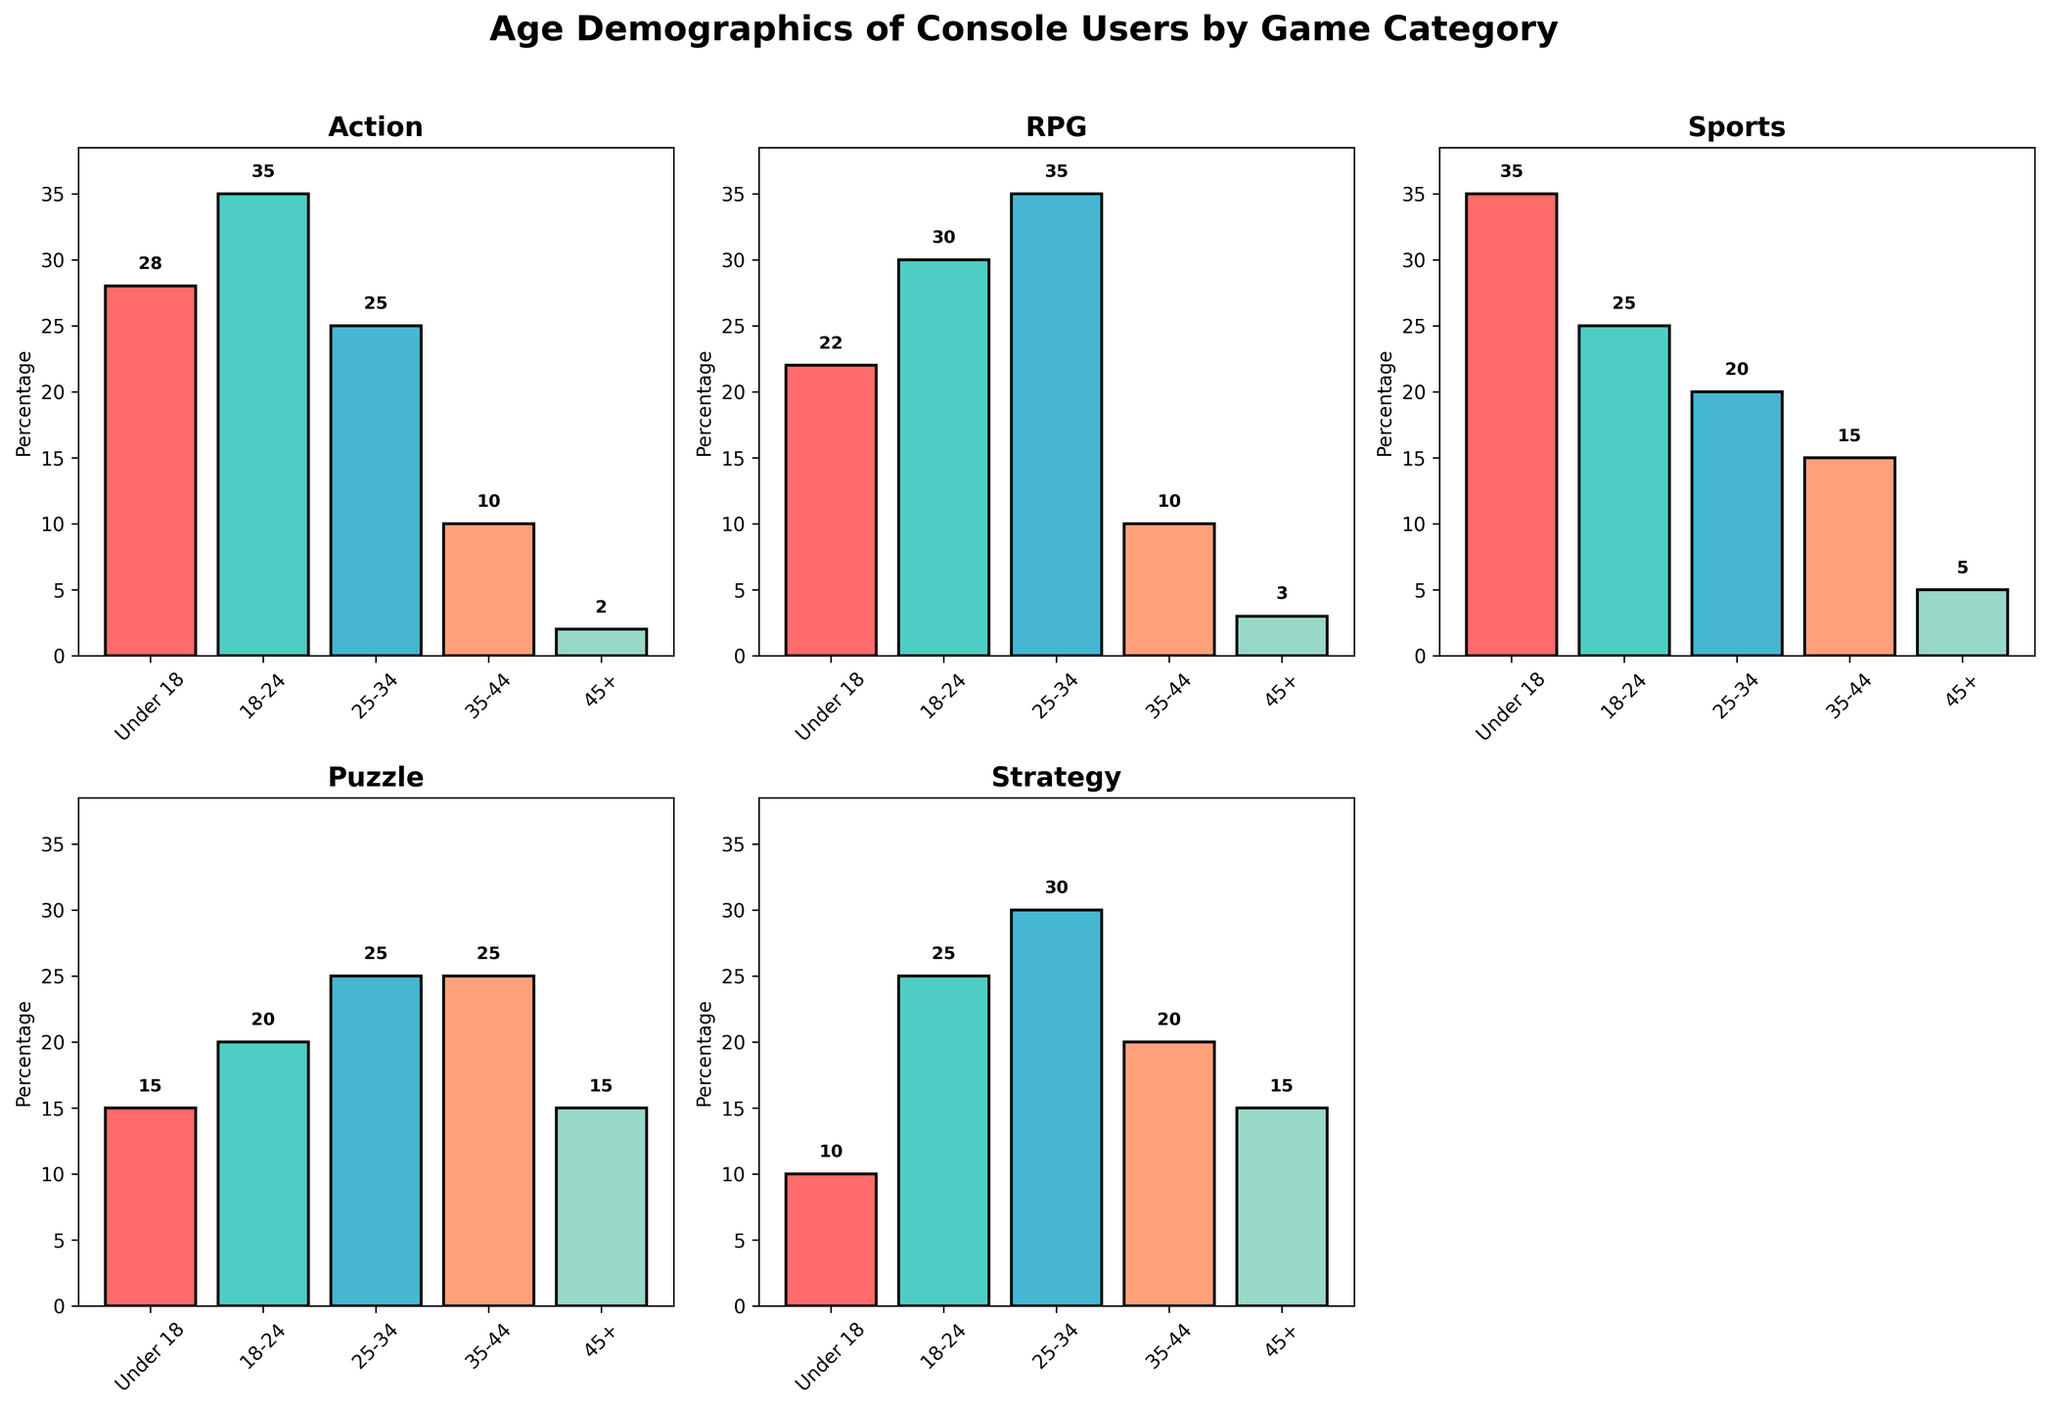What is the title of the figure? The title of the figure is displayed at the top of the chart. It reads "Age Demographics of Console Users by Game Category."
Answer: Age Demographics of Console Users by Game Category Which age group is the most represented in the Action category? Referring to the bar labeled "Action," the tallest bar corresponds to the "18-24" age group.
Answer: 18-24 Compare the popularity of Sports games between the age groups "Under 18" and "35-44". Which is higher? Looking at the bars under the "Sports" category, the bar for "Under 18" is taller than the bar for "35-44".
Answer: Under 18 What is the percentage of users aged 45+ in the Puzzle category? Observe the bar corresponding to the "45+" group under the "Puzzle" category. The height of the bar is labeled 15.
Answer: 15 Is the percentage of "18-24" users in the RPG category higher than in the Strategy category? Compare the bar heights under the "18-24" group for both RPG and Strategy categories.  The RPG bar is taller (30 vs. 25).
Answer: Yes What is the total percentage of users aged "25-34" across all game categories? Sum the values of the "25-34" age group across all categories: 25 (Action) + 35 (RPG) + 20 (Sports) + 25 (Puzzle) + 30 (Strategy).
Answer: 135 Which game category has the least representation from the "45+" age group? Look at the heights of all bars for the "45+" group. The shortest one is found in the "Action" category.
Answer: Action Which age group has the lowest percentage in the RPG category? Observe the bars under the RPG category. The shortest bar corresponds to the "45+" group.
Answer: 45+ In which category do users aged "35-44" have the highest percentage? Check the bars for the age group "35-44" across all categories. The tallest bar is in the Puzzle category.
Answer: Puzzle What is the difference in percentage points between the "18-24" and "25-34" age groups in the Strategy category? The value for "18-24" in Strategy is 25, and for "25-34" it is 30. The difference is 30 - 25 = 5 percentage points.
Answer: 5 